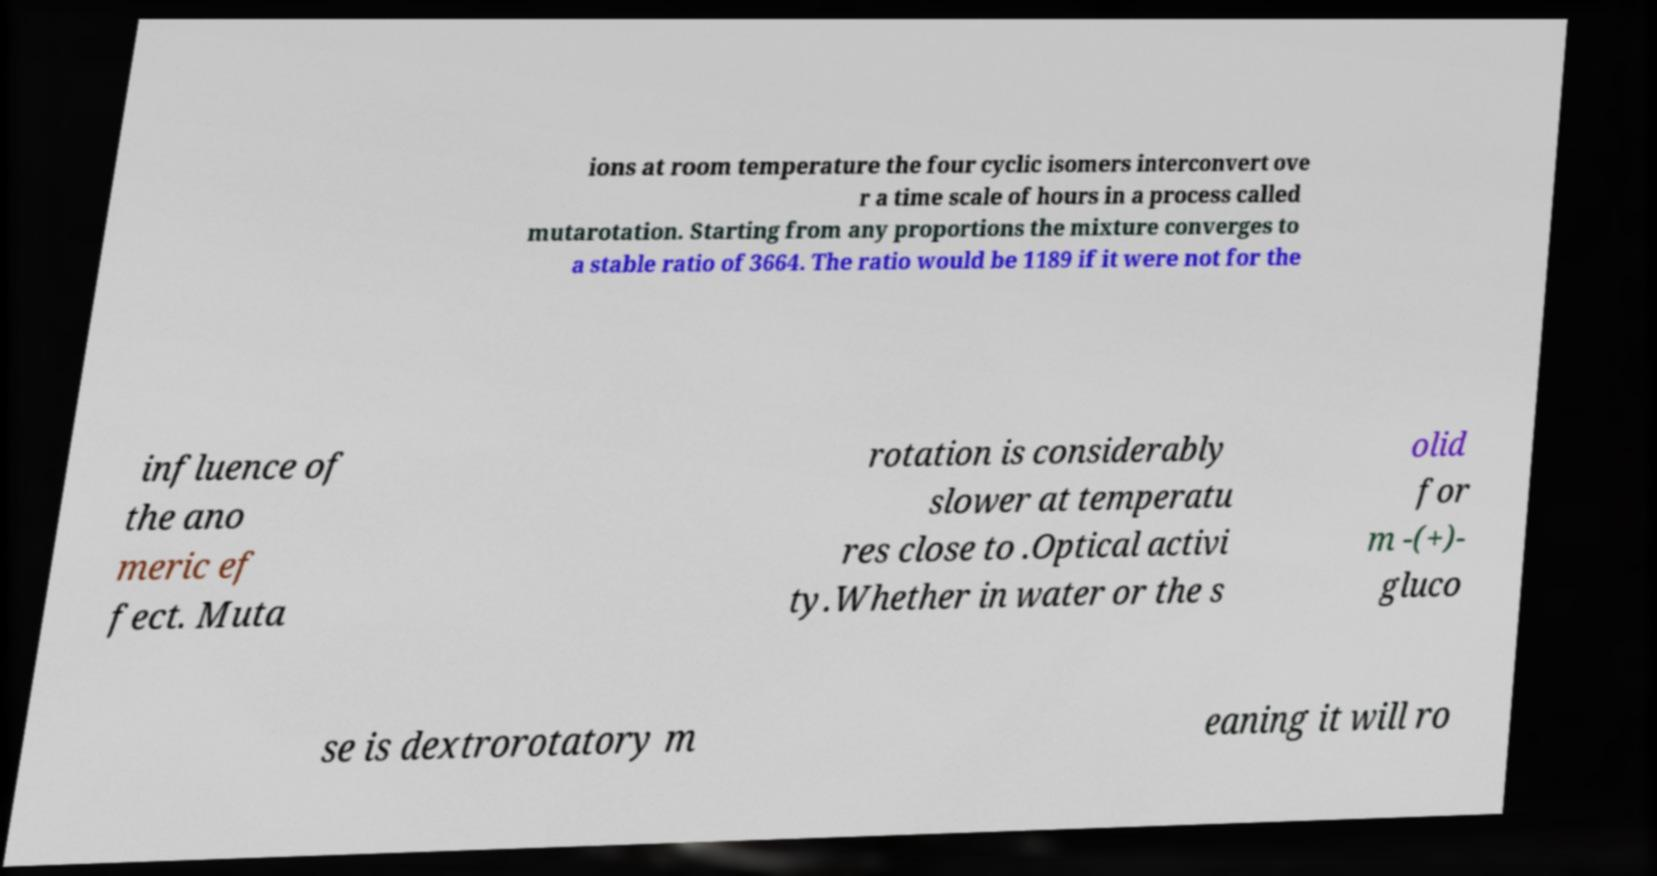Could you extract and type out the text from this image? ions at room temperature the four cyclic isomers interconvert ove r a time scale of hours in a process called mutarotation. Starting from any proportions the mixture converges to a stable ratio of 3664. The ratio would be 1189 if it were not for the influence of the ano meric ef fect. Muta rotation is considerably slower at temperatu res close to .Optical activi ty.Whether in water or the s olid for m -(+)- gluco se is dextrorotatory m eaning it will ro 